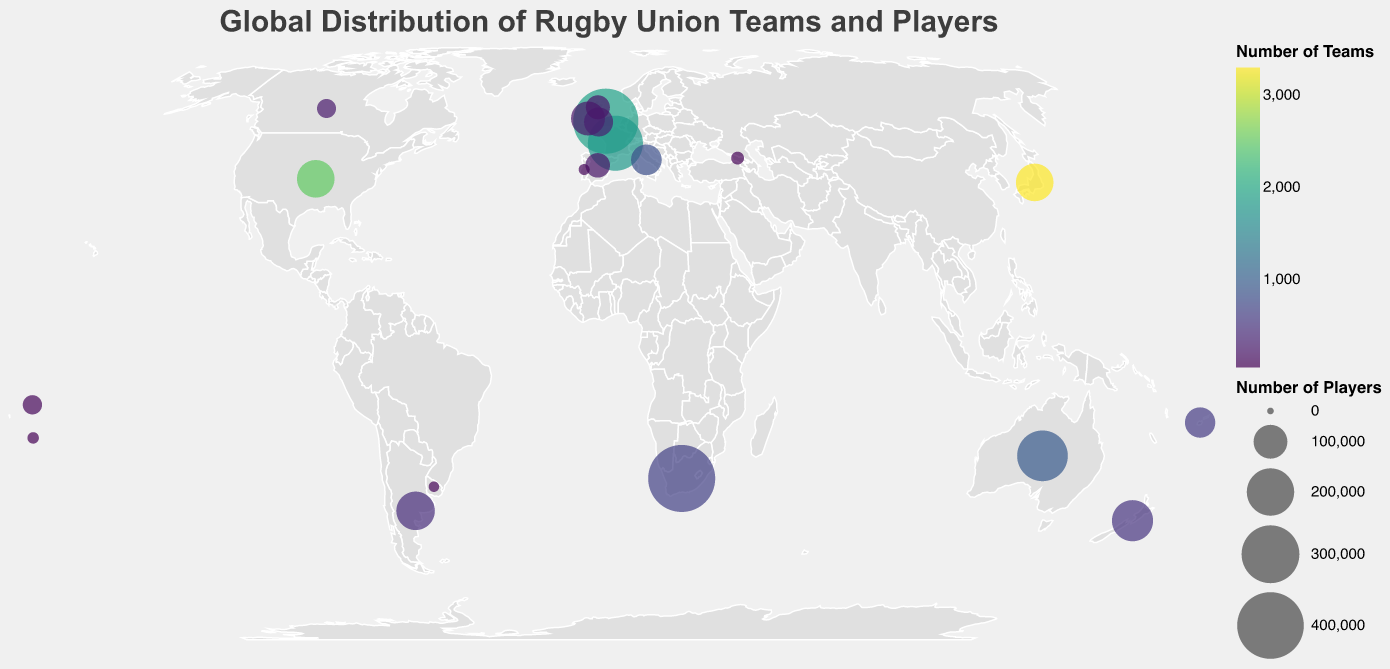What is the title of the map? The title of the map is prominently displayed at the top of the figure.
Answer: Global Distribution of Rugby Union Teams and Players Which country has the highest number of rugby players? The size of the circles represents the number of players, and the largest circle can be found in South Africa.
Answer: South Africa Which country has the largest number of rugby teams? The color intensity of the circles represents the number of teams, and the most intense color is in Japan.
Answer: Japan How many countries have more than 200 thousand rugby players? By visually inspecting the size of the circles, England, South Africa, Australia, and France have circles large enough to indicate over 200,000 players.
Answer: Four countries Which two countries have almost the same number of rugby players? By comparing the size of the circles, we can see that Japan and the USA have similarly sized circles.
Answer: Japan and USA What is the color scheme used to represent the number of rugby teams? The color of the circles follows a gradient from light to dark, indicating a scheme used, which is viridis.
Answer: Viridis Which country in South America has a significant number of rugby players and teams? By identifying the location in South America with a noticeable circle, Argentina stands out as having a significant number of players and teams.
Answer: Argentina Compare the number of rugby teams in New Zealand and Canada. Which country has more? By looking at the circle color, New Zealand's circle is a bit more saturated than Canada's, indicating it has more teams.
Answer: New Zealand What is the difference in player count between England and Wales? England has 382,000 players and Wales has 73,000 players, subtracting Wales' count from England's gives us: 382,000 - 73,000.
Answer: 309,000 How does Italy compare to Japan regarding the number of rugby teams? Italy's circle is less saturated compared to Japan's, indicating that Japan has significantly more teams.
Answer: Japan has more teams 